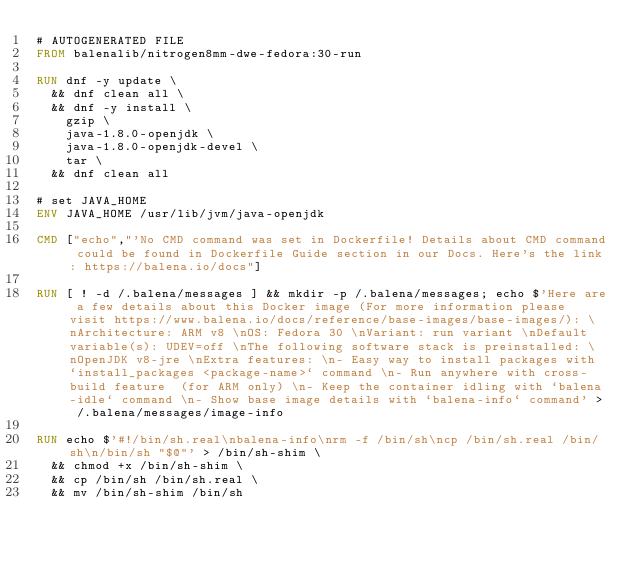Convert code to text. <code><loc_0><loc_0><loc_500><loc_500><_Dockerfile_># AUTOGENERATED FILE
FROM balenalib/nitrogen8mm-dwe-fedora:30-run

RUN dnf -y update \
	&& dnf clean all \
	&& dnf -y install \
		gzip \
		java-1.8.0-openjdk \
		java-1.8.0-openjdk-devel \
		tar \
	&& dnf clean all

# set JAVA_HOME
ENV JAVA_HOME /usr/lib/jvm/java-openjdk

CMD ["echo","'No CMD command was set in Dockerfile! Details about CMD command could be found in Dockerfile Guide section in our Docs. Here's the link: https://balena.io/docs"]

RUN [ ! -d /.balena/messages ] && mkdir -p /.balena/messages; echo $'Here are a few details about this Docker image (For more information please visit https://www.balena.io/docs/reference/base-images/base-images/): \nArchitecture: ARM v8 \nOS: Fedora 30 \nVariant: run variant \nDefault variable(s): UDEV=off \nThe following software stack is preinstalled: \nOpenJDK v8-jre \nExtra features: \n- Easy way to install packages with `install_packages <package-name>` command \n- Run anywhere with cross-build feature  (for ARM only) \n- Keep the container idling with `balena-idle` command \n- Show base image details with `balena-info` command' > /.balena/messages/image-info

RUN echo $'#!/bin/sh.real\nbalena-info\nrm -f /bin/sh\ncp /bin/sh.real /bin/sh\n/bin/sh "$@"' > /bin/sh-shim \
	&& chmod +x /bin/sh-shim \
	&& cp /bin/sh /bin/sh.real \
	&& mv /bin/sh-shim /bin/sh</code> 